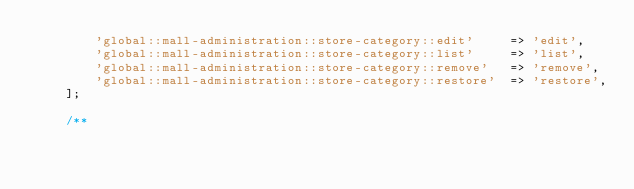Convert code to text. <code><loc_0><loc_0><loc_500><loc_500><_PHP_>        'global::mall-administration::store-category::edit'     => 'edit',
        'global::mall-administration::store-category::list'     => 'list',
        'global::mall-administration::store-category::remove'   => 'remove',
        'global::mall-administration::store-category::restore'  => 'restore',
    ];

    /**</code> 